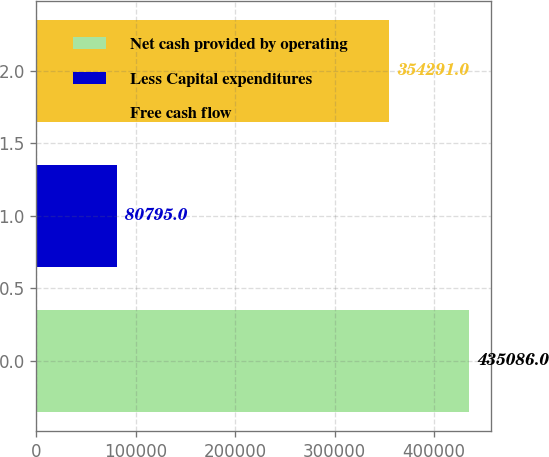Convert chart. <chart><loc_0><loc_0><loc_500><loc_500><bar_chart><fcel>Net cash provided by operating<fcel>Less Capital expenditures<fcel>Free cash flow<nl><fcel>435086<fcel>80795<fcel>354291<nl></chart> 